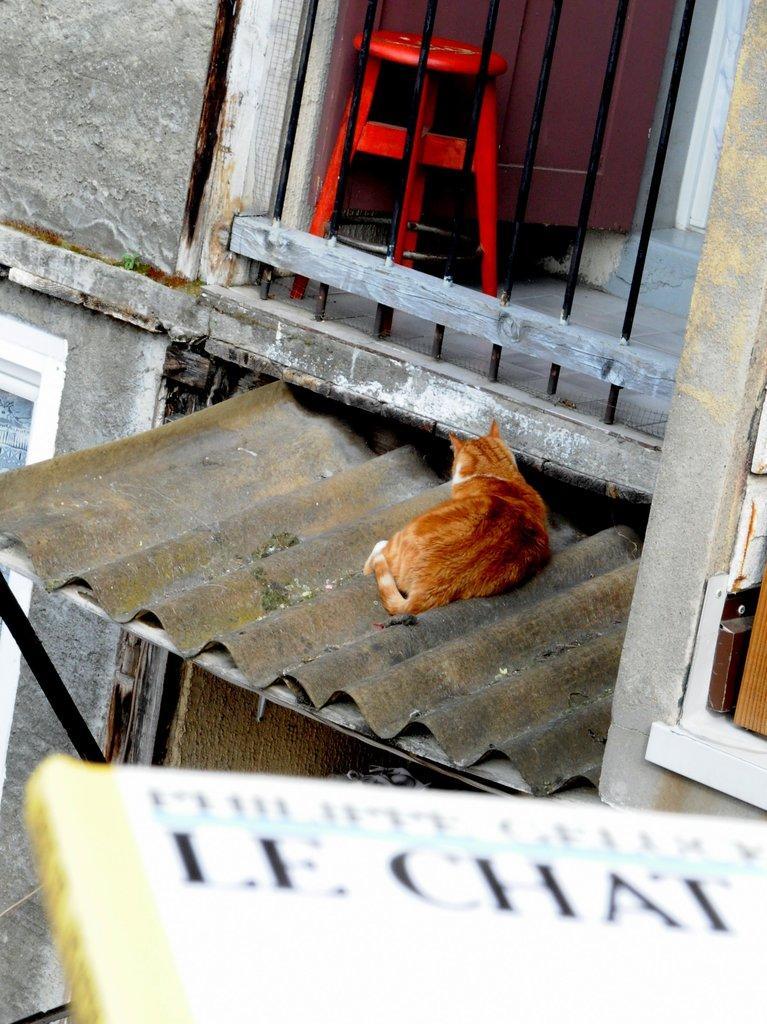Please provide a concise description of this image. In this image we can see the building and there is a cat sitting on the roof. We can see a stool near the railing and at the bottom of the image, we can see a board with some text. 